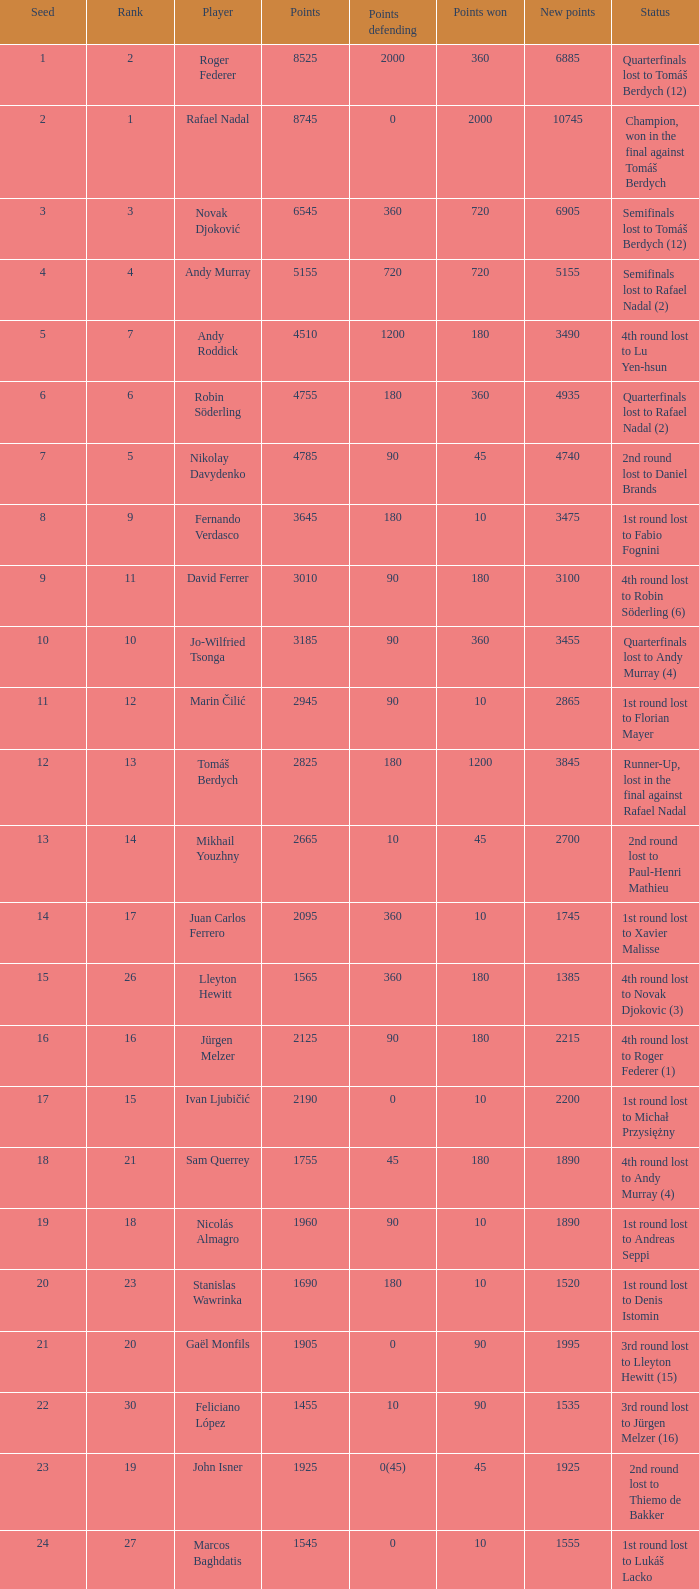Name the number of points defending for 1075 1.0. 